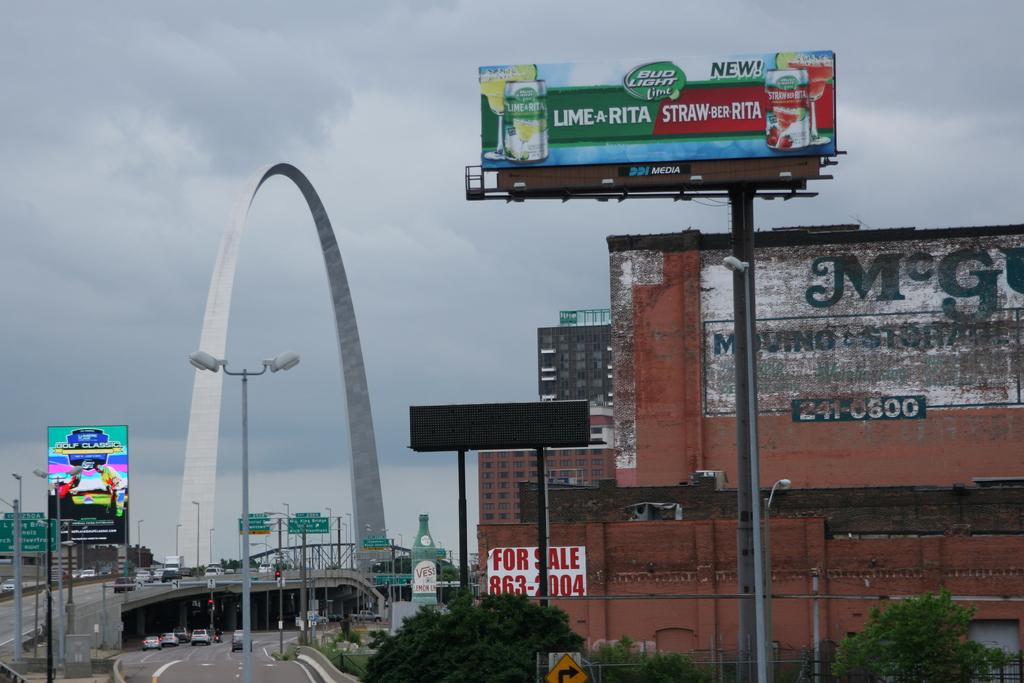Provide a one-sentence caption for the provided image. A billboard near the arch advertises Bud Light. 